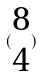<formula> <loc_0><loc_0><loc_500><loc_500>( \begin{matrix} 8 \\ 4 \end{matrix} )</formula> 